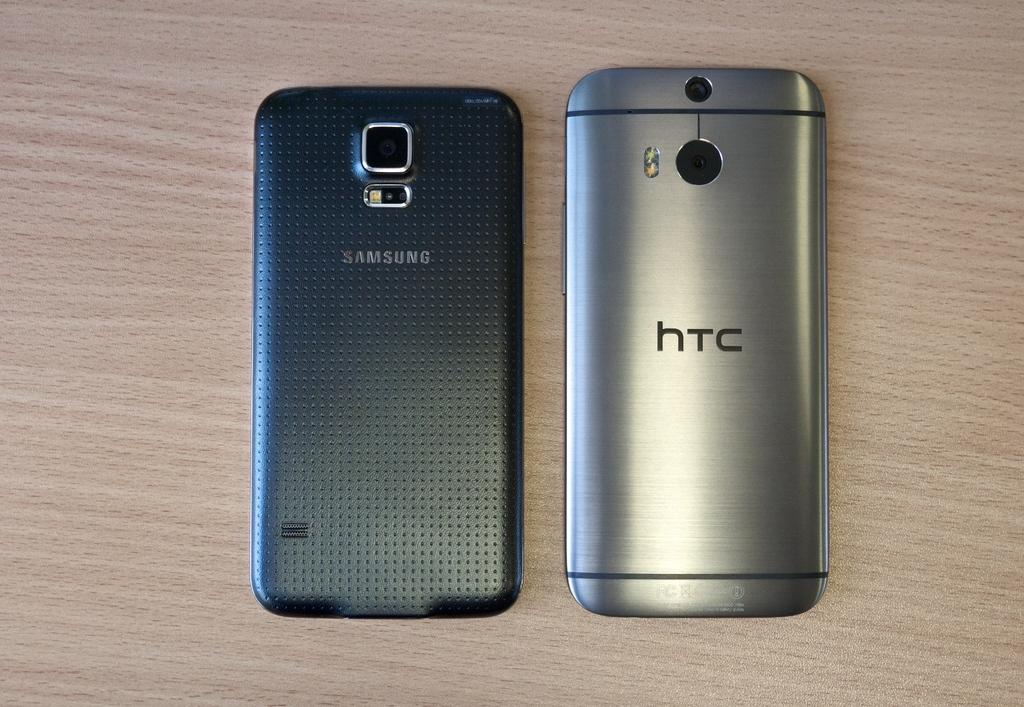Provide a one-sentence caption for the provided image. two models of phones, one is a SAMSUNG and other is a hTC. 